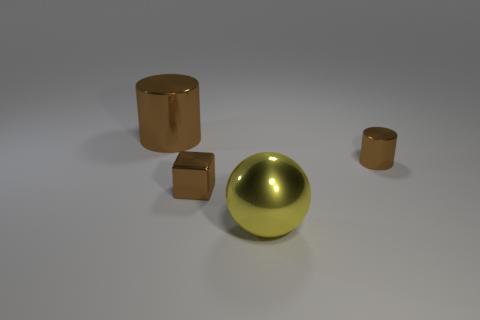Subtract all brown cylinders. How many were subtracted if there are1brown cylinders left? 1 Subtract all blocks. How many objects are left? 3 Add 1 brown cylinders. How many objects exist? 5 Subtract 2 cylinders. How many cylinders are left? 0 Subtract all purple cubes. How many gray spheres are left? 0 Add 1 small brown cylinders. How many small brown cylinders are left? 2 Add 4 big brown cylinders. How many big brown cylinders exist? 5 Subtract 0 cyan cylinders. How many objects are left? 4 Subtract all cyan spheres. Subtract all cyan cubes. How many spheres are left? 1 Subtract all yellow spheres. Subtract all brown objects. How many objects are left? 0 